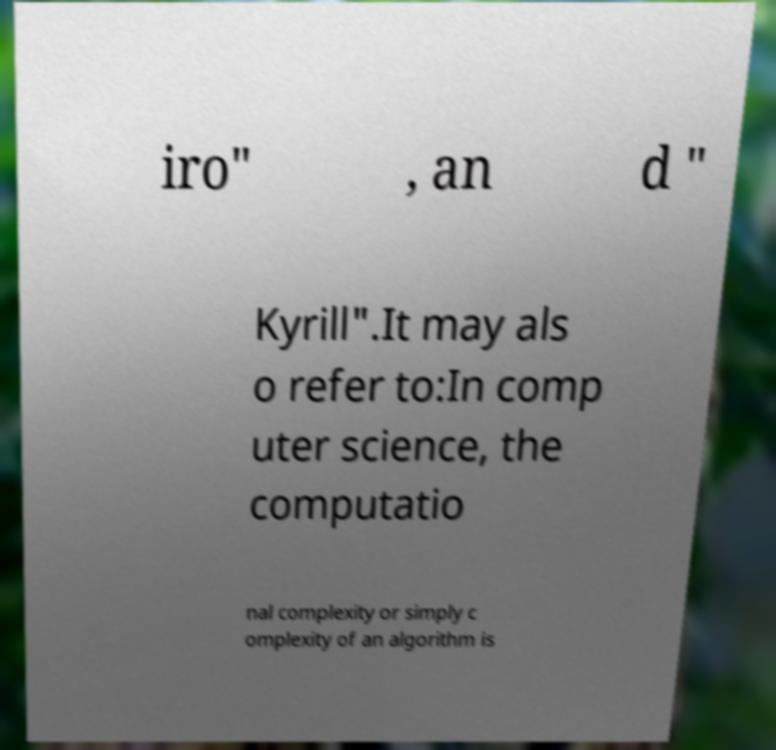I need the written content from this picture converted into text. Can you do that? iro" , an d " Kyrill".It may als o refer to:In comp uter science, the computatio nal complexity or simply c omplexity of an algorithm is 